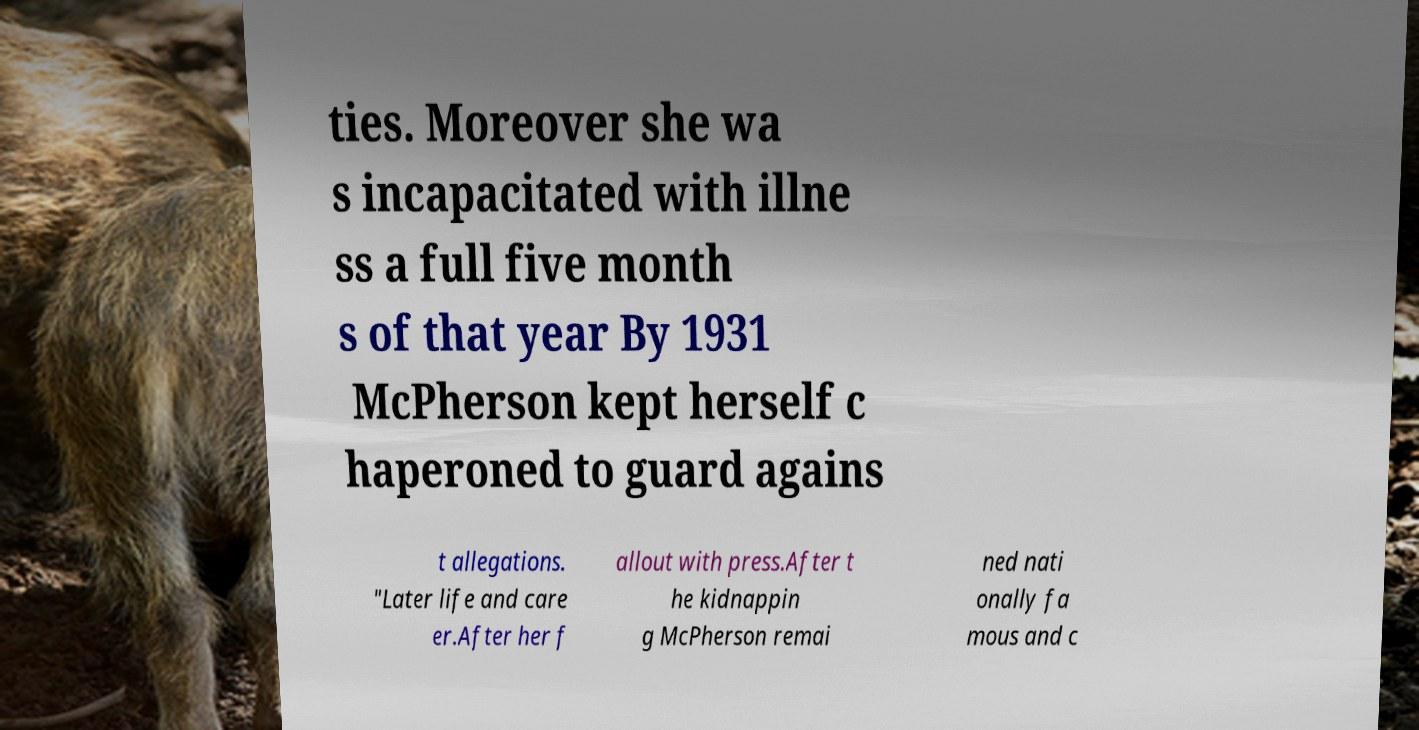For documentation purposes, I need the text within this image transcribed. Could you provide that? ties. Moreover she wa s incapacitated with illne ss a full five month s of that year By 1931 McPherson kept herself c haperoned to guard agains t allegations. "Later life and care er.After her f allout with press.After t he kidnappin g McPherson remai ned nati onally fa mous and c 